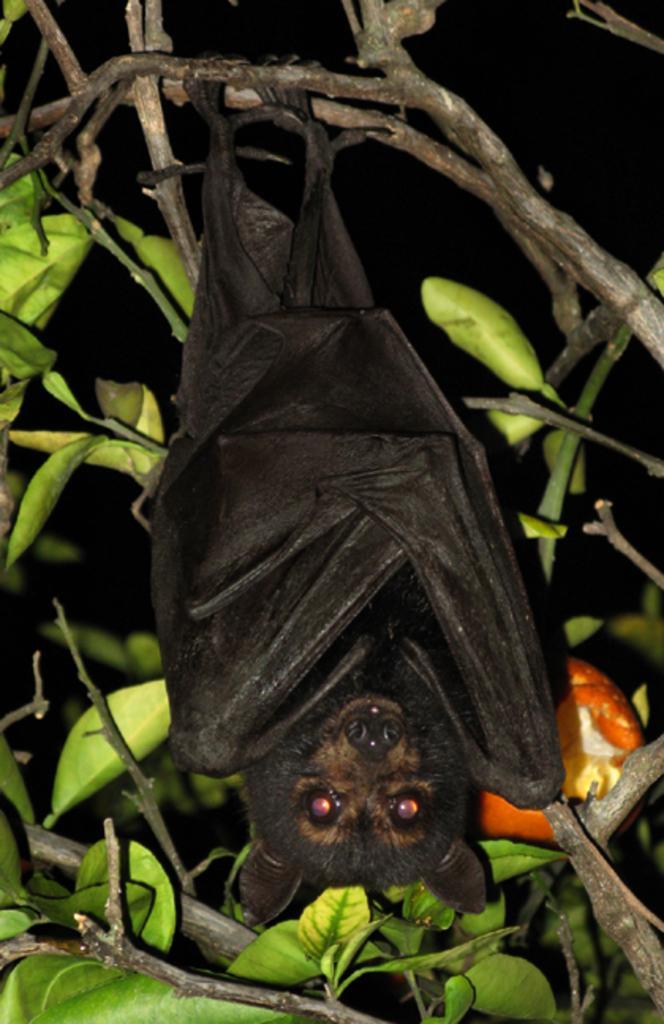Describe this image in one or two sentences. In this picture we can see a bat is hanging to the branch. Behind the bed, there are leaves and the dark background. 